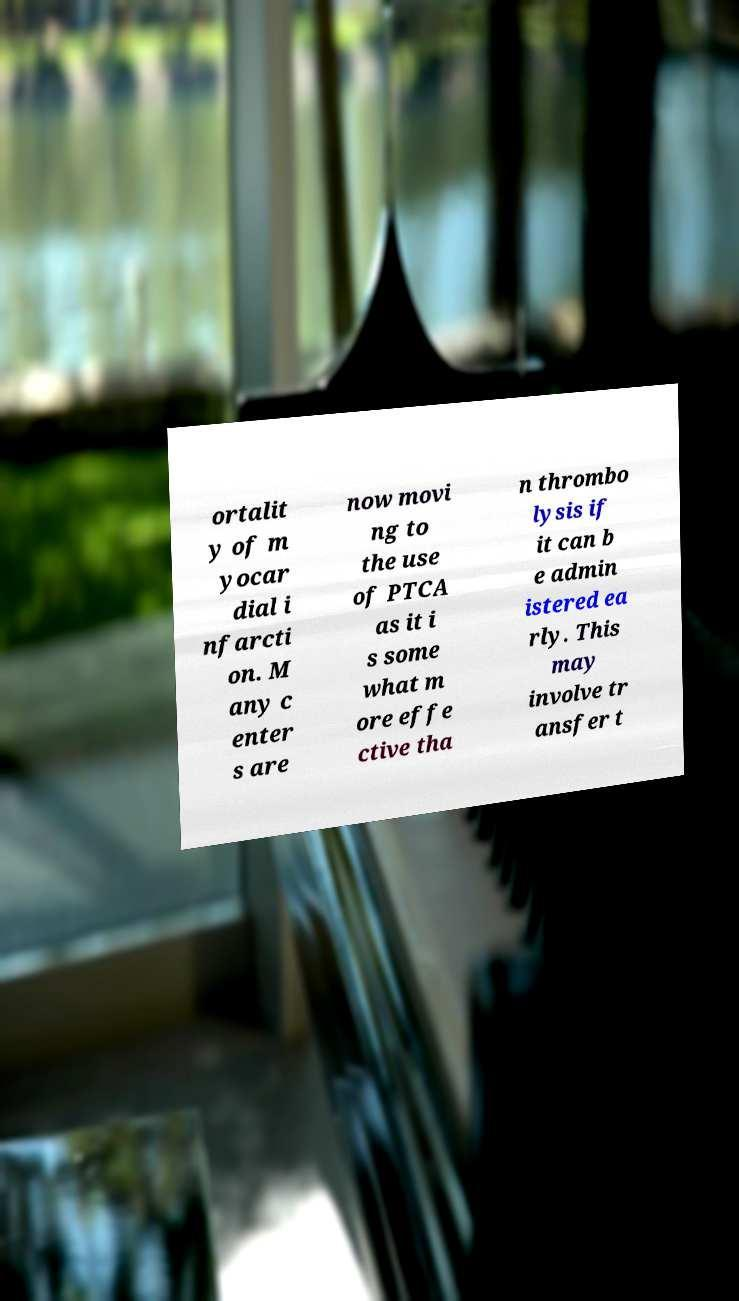Please identify and transcribe the text found in this image. ortalit y of m yocar dial i nfarcti on. M any c enter s are now movi ng to the use of PTCA as it i s some what m ore effe ctive tha n thrombo lysis if it can b e admin istered ea rly. This may involve tr ansfer t 